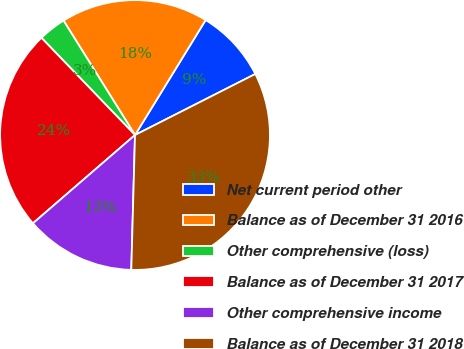Convert chart. <chart><loc_0><loc_0><loc_500><loc_500><pie_chart><fcel>Net current period other<fcel>Balance as of December 31 2016<fcel>Other comprehensive (loss)<fcel>Balance as of December 31 2017<fcel>Other comprehensive income<fcel>Balance as of December 31 2018<nl><fcel>8.76%<fcel>17.65%<fcel>3.31%<fcel>24.15%<fcel>13.21%<fcel>32.91%<nl></chart> 